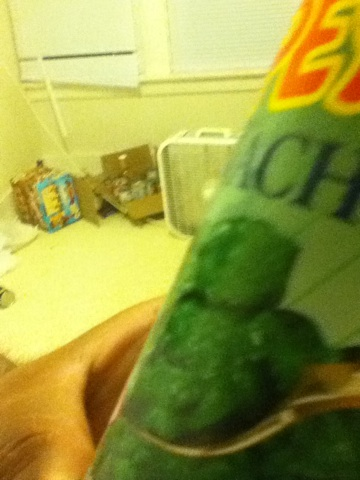What is this can? This can contains spinach. While the image is blurry, and specifics like the brand or nutritional content cannot be discerned, it is identifiable by the distinctive green color and texture visible through the transparent lid. 